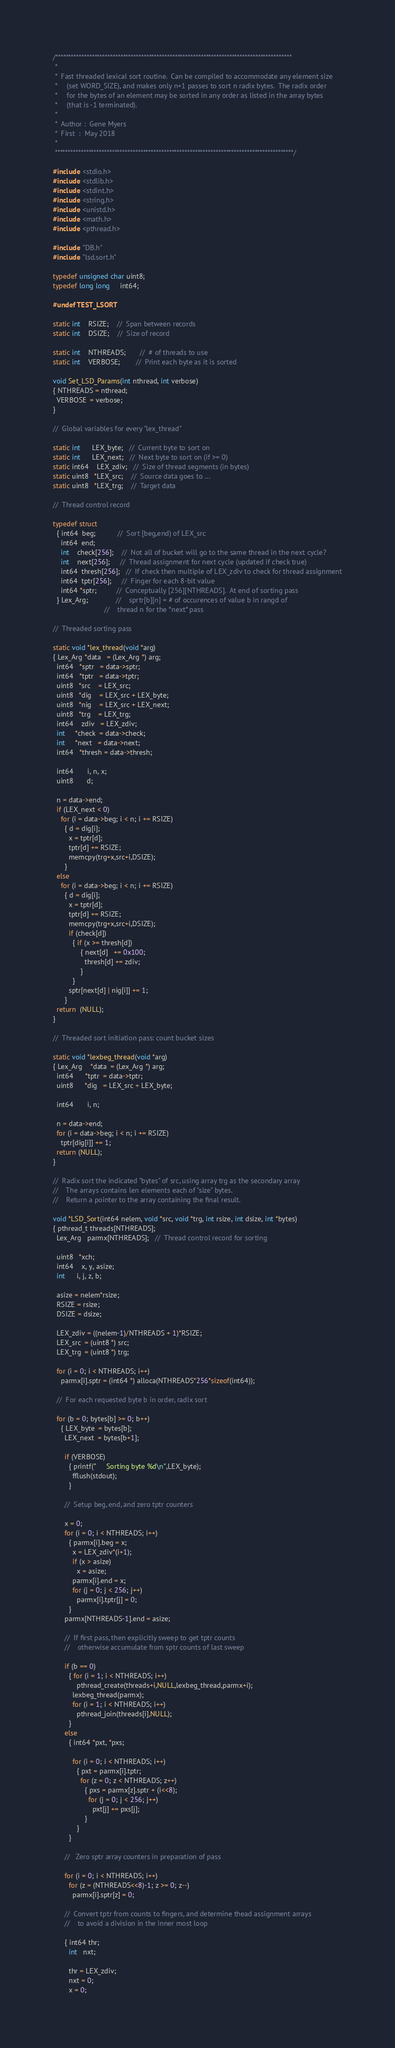Convert code to text. <code><loc_0><loc_0><loc_500><loc_500><_C_>/*******************************************************************************************
 *
 *  Fast threaded lexical sort routine.  Can be compiled to accommodate any element size
 *     (set WORD_SIZE), and makes only n+1 passes to sort n radix bytes.  The radix order
 *     for the bytes of an element may be sorted in any order as listed in the array bytes
 *     (that is -1 terminated).
 *
 *  Author :  Gene Myers
 *  First  :  May 2018
 *
 ********************************************************************************************/

#include <stdio.h>
#include <stdlib.h>
#include <stdint.h>
#include <string.h>
#include <unistd.h>
#include <math.h>
#include <pthread.h>

#include "DB.h"
#include "lsd.sort.h"

typedef unsigned char uint8;
typedef long long     int64;

#undef TEST_LSORT

static int    RSIZE;    //  Span between records
static int    DSIZE;    //  Size of record

static int    NTHREADS;       //  # of threads to use
static int    VERBOSE;        //  Print each byte as it is sorted

void Set_LSD_Params(int nthread, int verbose)
{ NTHREADS = nthread;
  VERBOSE  = verbose;
}

//  Global variables for every "lex_thread"

static int      LEX_byte;   //  Current byte to sort on
static int      LEX_next;   //  Next byte to sort on (if >= 0)
static int64    LEX_zdiv;   //  Size of thread segments (in bytes)
static uint8   *LEX_src;    //  Source data goes to ...
static uint8   *LEX_trg;    //  Target data

//  Thread control record

typedef struct
  { int64  beg;           //  Sort [beg,end) of LEX_src
    int64  end;
    int    check[256];    //  Not all of bucket will go to the same thread in the next cycle?
    int    next[256];     //  Thread assignment for next cycle (updated if check true)
    int64  thresh[256];   //  If check then multiple of LEX_zdiv to check for thread assignment
    int64  tptr[256];     //  Finger for each 8-bit value
    int64 *sptr;          //  Conceptually [256][NTHREADS].  At end of sorting pass
  } Lex_Arg;              //    sprtr[b][n] = # of occurences of value b in rangd of
                          //    thread n for the *next* pass

//  Threaded sorting pass

static void *lex_thread(void *arg)
{ Lex_Arg *data   = (Lex_Arg *) arg;
  int64   *sptr   = data->sptr;
  int64   *tptr   = data->tptr;
  uint8   *src    = LEX_src;
  uint8   *dig    = LEX_src + LEX_byte;
  uint8   *nig    = LEX_src + LEX_next;
  uint8   *trg    = LEX_trg;
  int64    zdiv   = LEX_zdiv;
  int     *check  = data->check;
  int     *next   = data->next;
  int64   *thresh = data->thresh;

  int64       i, n, x;
  uint8       d;

  n = data->end;
  if (LEX_next < 0)
    for (i = data->beg; i < n; i += RSIZE)
      { d = dig[i];
        x = tptr[d];
        tptr[d] += RSIZE;
        memcpy(trg+x,src+i,DSIZE);
      }
  else
    for (i = data->beg; i < n; i += RSIZE)
      { d = dig[i];
        x = tptr[d];
        tptr[d] += RSIZE;
        memcpy(trg+x,src+i,DSIZE);
        if (check[d])
          { if (x >= thresh[d])
              { next[d]   += 0x100;
                thresh[d] += zdiv;
              }
          }
        sptr[next[d] | nig[i]] += 1;
      }
  return  (NULL);
}

//  Threaded sort initiation pass: count bucket sizes

static void *lexbeg_thread(void *arg)
{ Lex_Arg    *data  = (Lex_Arg *) arg;
  int64      *tptr  = data->tptr;
  uint8      *dig   = LEX_src + LEX_byte;

  int64       i, n;

  n = data->end;
  for (i = data->beg; i < n; i += RSIZE)
    tptr[dig[i]] += 1;
  return (NULL);
}

//  Radix sort the indicated "bytes" of src, using array trg as the secondary array
//    The arrays contains len elements each of "size" bytes.
//    Return a pointer to the array containing the final result.

void *LSD_Sort(int64 nelem, void *src, void *trg, int rsize, int dsize, int *bytes)
{ pthread_t threads[NTHREADS];
  Lex_Arg   parmx[NTHREADS];   //  Thread control record for sorting

  uint8   *xch;
  int64    x, y, asize;
  int      i, j, z, b;

  asize = nelem*rsize;
  RSIZE = rsize;
  DSIZE = dsize;

  LEX_zdiv = ((nelem-1)/NTHREADS + 1)*RSIZE;
  LEX_src  = (uint8 *) src;
  LEX_trg  = (uint8 *) trg;

  for (i = 0; i < NTHREADS; i++)
    parmx[i].sptr = (int64 *) alloca(NTHREADS*256*sizeof(int64));

  //  For each requested byte b in order, radix sort

  for (b = 0; bytes[b] >= 0; b++)
    { LEX_byte  = bytes[b];
      LEX_next  = bytes[b+1];

      if (VERBOSE)
        { printf("     Sorting byte %d\n",LEX_byte);
          fflush(stdout);
        }

      //  Setup beg, end, and zero tptr counters

      x = 0;
      for (i = 0; i < NTHREADS; i++)
        { parmx[i].beg = x;
          x = LEX_zdiv*(i+1);
          if (x > asize)
            x = asize;
          parmx[i].end = x;
          for (j = 0; j < 256; j++)
            parmx[i].tptr[j] = 0;
        }
      parmx[NTHREADS-1].end = asize;

      //  If first pass, then explicitly sweep to get tptr counts
      //    otherwise accumulate from sptr counts of last sweep

      if (b == 0)
        { for (i = 1; i < NTHREADS; i++)
            pthread_create(threads+i,NULL,lexbeg_thread,parmx+i);
          lexbeg_thread(parmx);
          for (i = 1; i < NTHREADS; i++)
            pthread_join(threads[i],NULL);
        }
      else
        { int64 *pxt, *pxs;

          for (i = 0; i < NTHREADS; i++)
            { pxt = parmx[i].tptr;
              for (z = 0; z < NTHREADS; z++)
                { pxs = parmx[z].sptr + (i<<8);
                  for (j = 0; j < 256; j++)
                    pxt[j] += pxs[j];
                }
            }
        }

      //   Zero sptr array counters in preparation of pass

      for (i = 0; i < NTHREADS; i++)
        for (z = (NTHREADS<<8)-1; z >= 0; z--)
          parmx[i].sptr[z] = 0;

      //  Convert tptr from counts to fingers, and determine thead assignment arrays
      //    to avoid a division in the inner most loop

      { int64 thr;
        int   nxt;

        thr = LEX_zdiv;
        nxt = 0;
        x = 0;</code> 